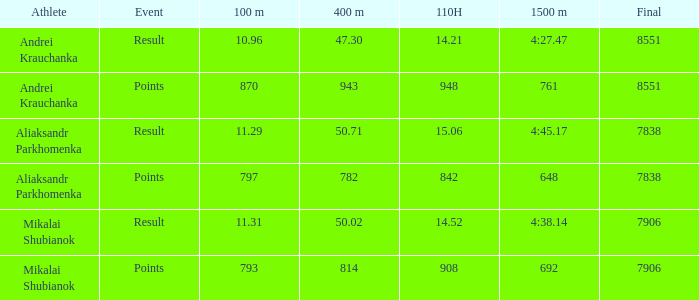What was the final for Mikalai Shubianok who had a 110H less than 908? 7906.0. 